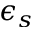Convert formula to latex. <formula><loc_0><loc_0><loc_500><loc_500>\epsilon _ { s }</formula> 